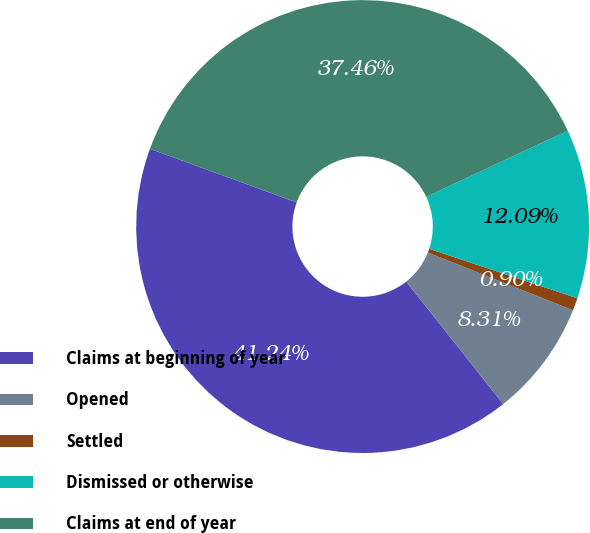<chart> <loc_0><loc_0><loc_500><loc_500><pie_chart><fcel>Claims at beginning of year<fcel>Opened<fcel>Settled<fcel>Dismissed or otherwise<fcel>Claims at end of year<nl><fcel>41.24%<fcel>8.31%<fcel>0.9%<fcel>12.09%<fcel>37.46%<nl></chart> 